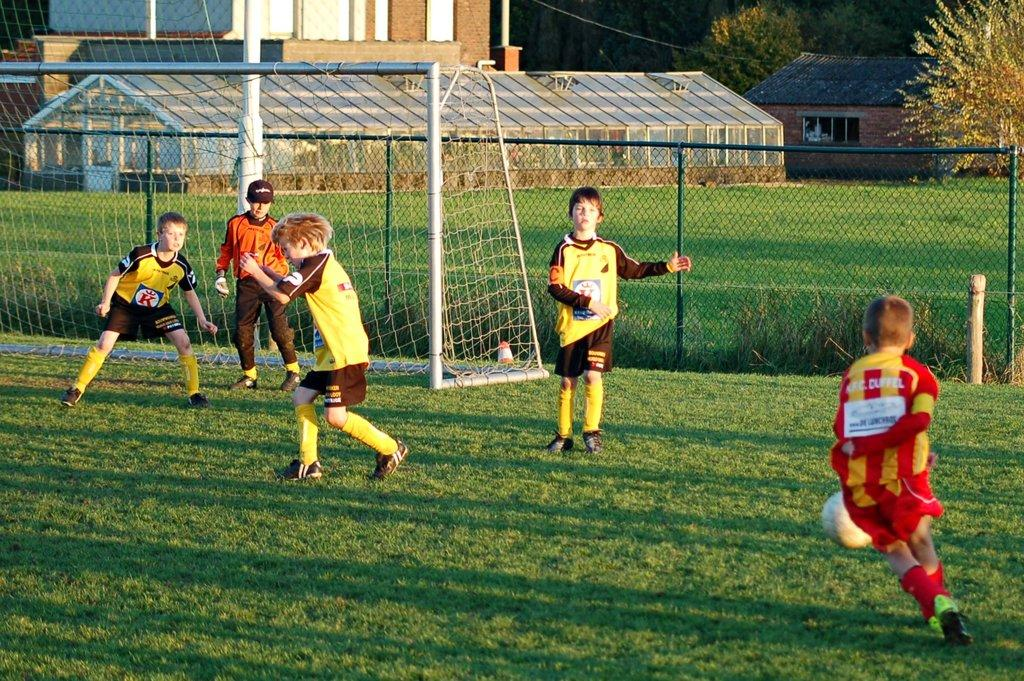<image>
Summarize the visual content of the image. many kids playing soccer and one with the word cuffel on their shirt 